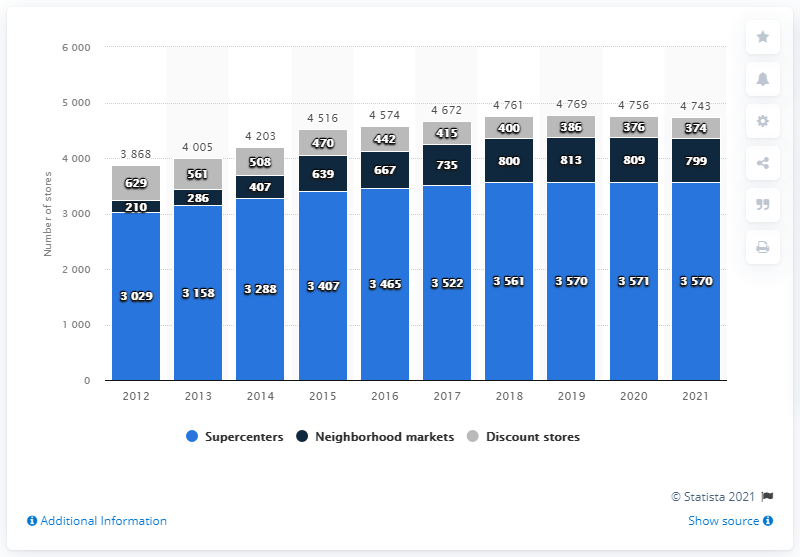Draw attention to some important aspects in this diagram. Yes, the gray bar values are decreasing over the years. In 2021, Walmart had 799 neighborhood markets. In 2021, Walmart had a total of 799 neighborhood markets across the United States, providing convenient access to essential products and services for local communities. 